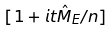Convert formula to latex. <formula><loc_0><loc_0><loc_500><loc_500>[ 1 + i t { \hat { M } } _ { E } / n ]</formula> 